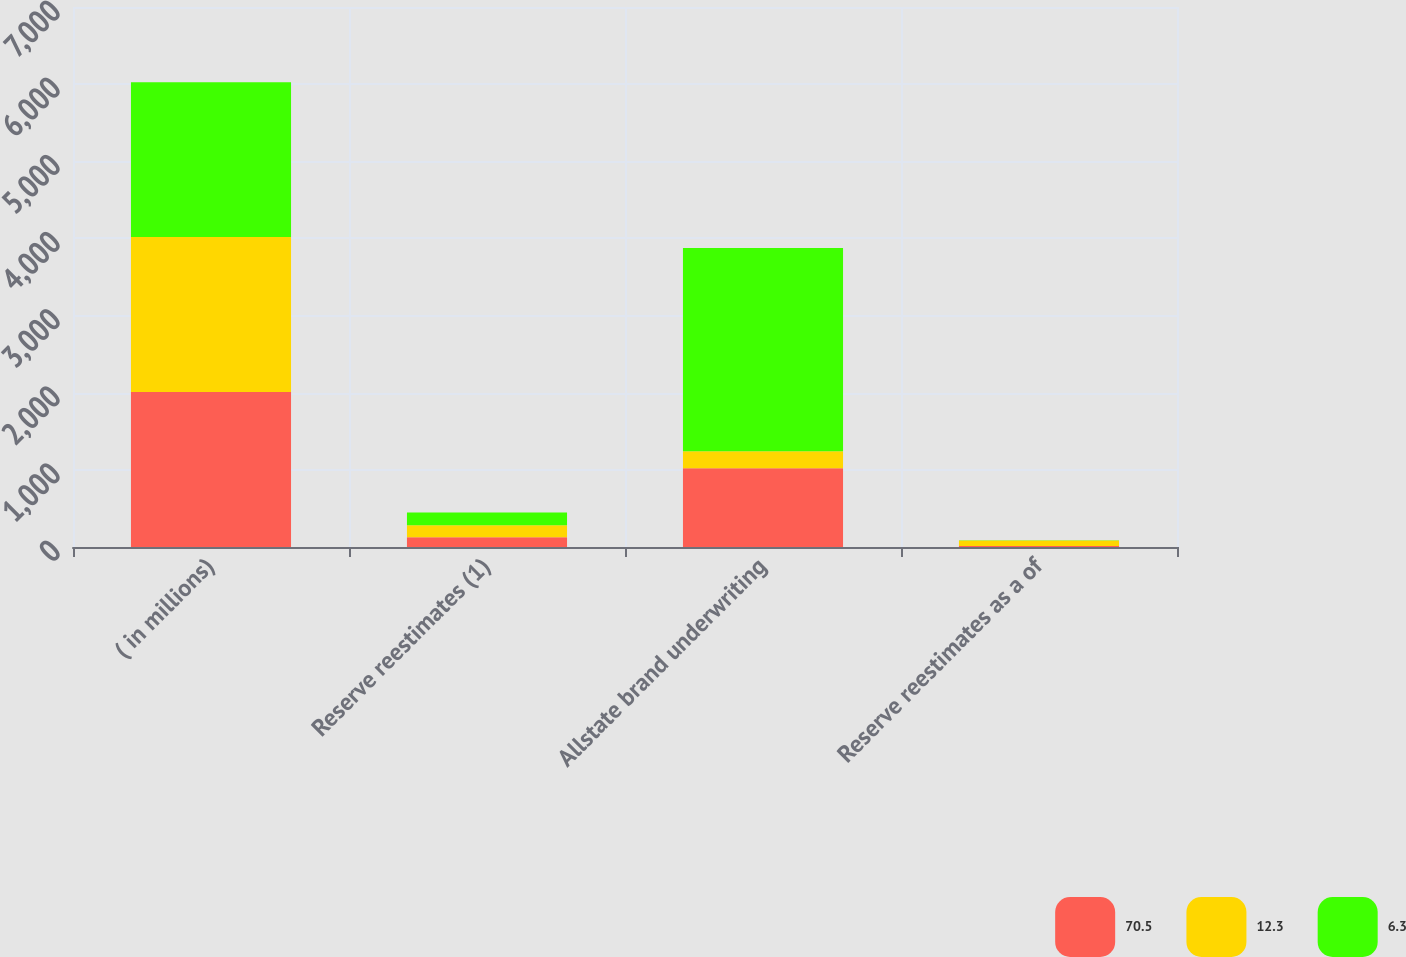Convert chart. <chart><loc_0><loc_0><loc_500><loc_500><stacked_bar_chart><ecel><fcel>( in millions)<fcel>Reserve reestimates (1)<fcel>Allstate brand underwriting<fcel>Reserve reestimates as a of<nl><fcel>70.5<fcel>2009<fcel>126<fcel>1022<fcel>12.3<nl><fcel>12.3<fcel>2008<fcel>155<fcel>220<fcel>70.5<nl><fcel>6.3<fcel>2007<fcel>167<fcel>2634<fcel>6.3<nl></chart> 